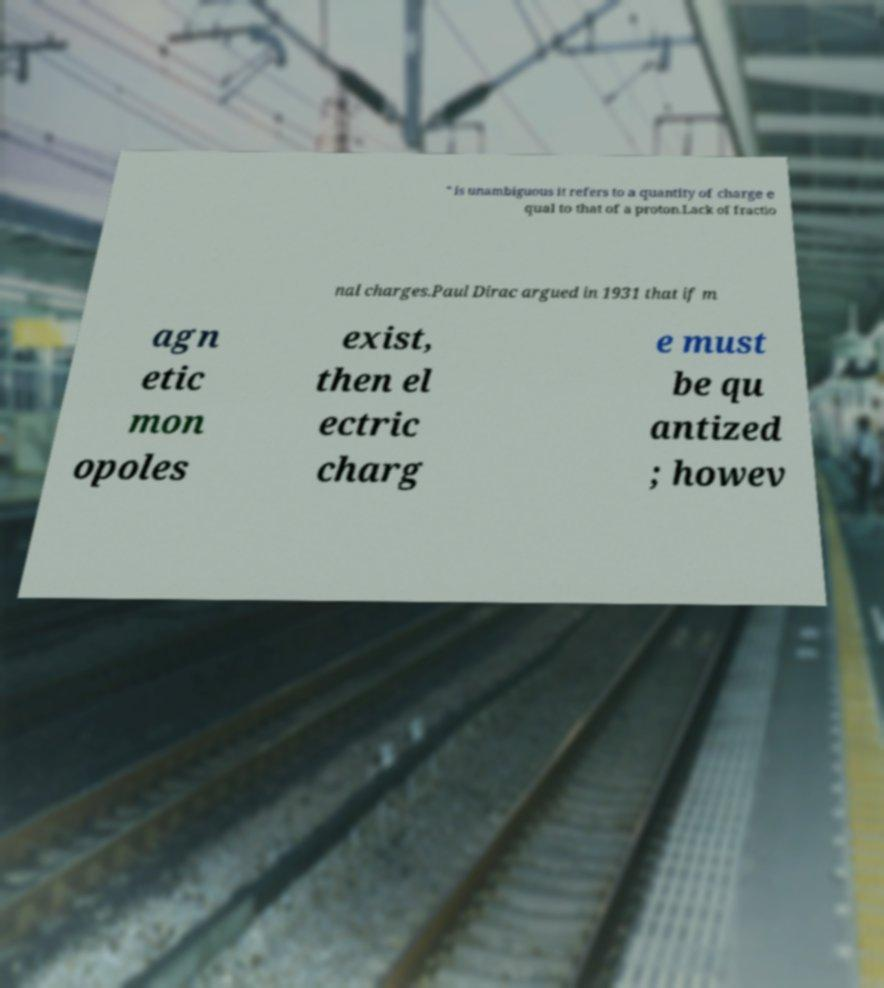There's text embedded in this image that I need extracted. Can you transcribe it verbatim? " is unambiguous it refers to a quantity of charge e qual to that of a proton.Lack of fractio nal charges.Paul Dirac argued in 1931 that if m agn etic mon opoles exist, then el ectric charg e must be qu antized ; howev 